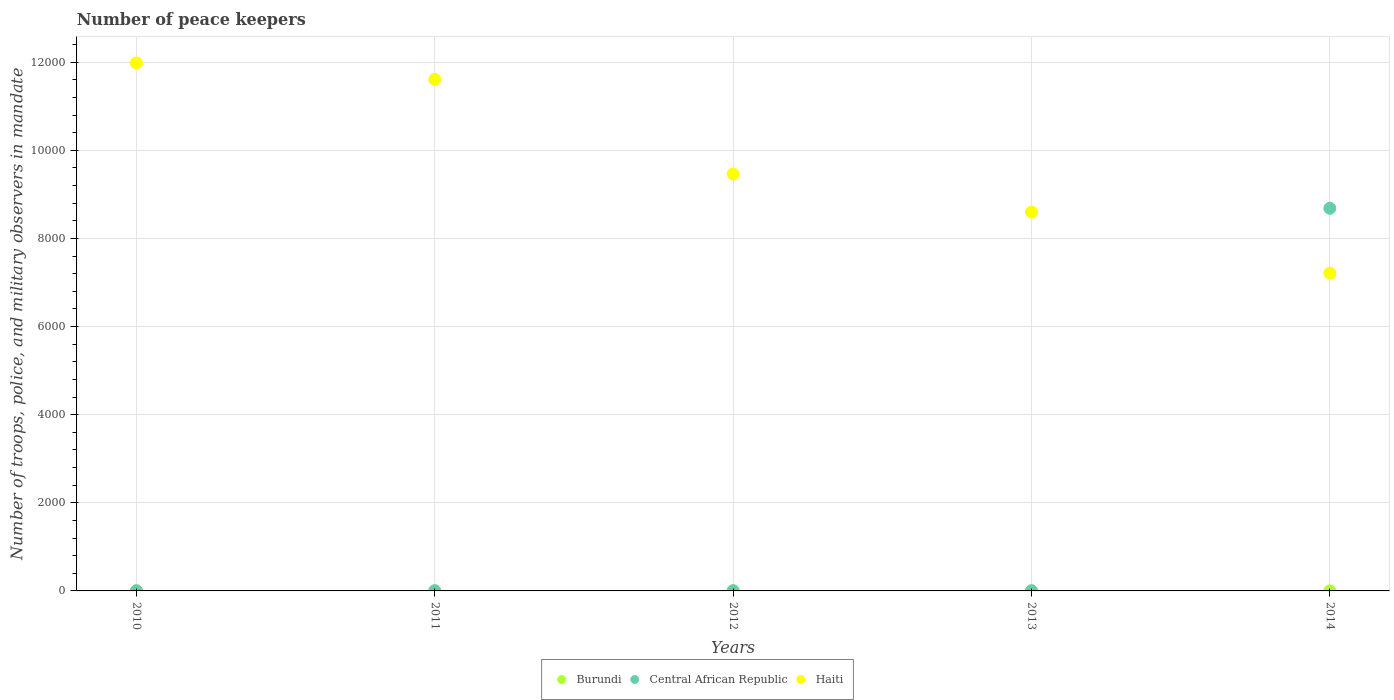How many different coloured dotlines are there?
Keep it short and to the point. 3. Is the number of dotlines equal to the number of legend labels?
Your response must be concise. Yes. What is the number of peace keepers in in Haiti in 2010?
Offer a very short reply. 1.20e+04. Across all years, what is the maximum number of peace keepers in in Burundi?
Offer a terse response. 4. Across all years, what is the minimum number of peace keepers in in Burundi?
Your answer should be very brief. 1. What is the total number of peace keepers in in Burundi in the graph?
Give a very brief answer. 11. What is the difference between the number of peace keepers in in Central African Republic in 2010 and that in 2011?
Your answer should be compact. -1. What is the difference between the number of peace keepers in in Central African Republic in 2013 and the number of peace keepers in in Haiti in 2014?
Provide a short and direct response. -7209. What is the average number of peace keepers in in Burundi per year?
Give a very brief answer. 2.2. In the year 2013, what is the difference between the number of peace keepers in in Central African Republic and number of peace keepers in in Burundi?
Offer a terse response. 2. In how many years, is the number of peace keepers in in Burundi greater than 1200?
Ensure brevity in your answer.  0. What is the ratio of the number of peace keepers in in Haiti in 2011 to that in 2013?
Make the answer very short. 1.35. What is the difference between the highest and the second highest number of peace keepers in in Central African Republic?
Ensure brevity in your answer.  8681. Is the sum of the number of peace keepers in in Burundi in 2011 and 2012 greater than the maximum number of peace keepers in in Haiti across all years?
Your answer should be very brief. No. Does the number of peace keepers in in Central African Republic monotonically increase over the years?
Make the answer very short. No. Is the number of peace keepers in in Central African Republic strictly greater than the number of peace keepers in in Haiti over the years?
Your answer should be compact. No. What is the difference between two consecutive major ticks on the Y-axis?
Provide a short and direct response. 2000. Are the values on the major ticks of Y-axis written in scientific E-notation?
Offer a terse response. No. Does the graph contain grids?
Offer a terse response. Yes. How many legend labels are there?
Give a very brief answer. 3. What is the title of the graph?
Ensure brevity in your answer.  Number of peace keepers. Does "Burkina Faso" appear as one of the legend labels in the graph?
Give a very brief answer. No. What is the label or title of the X-axis?
Keep it short and to the point. Years. What is the label or title of the Y-axis?
Your response must be concise. Number of troops, police, and military observers in mandate. What is the Number of troops, police, and military observers in mandate in Burundi in 2010?
Provide a short and direct response. 4. What is the Number of troops, police, and military observers in mandate in Central African Republic in 2010?
Offer a terse response. 3. What is the Number of troops, police, and military observers in mandate of Haiti in 2010?
Ensure brevity in your answer.  1.20e+04. What is the Number of troops, police, and military observers in mandate in Burundi in 2011?
Provide a succinct answer. 1. What is the Number of troops, police, and military observers in mandate in Central African Republic in 2011?
Offer a terse response. 4. What is the Number of troops, police, and military observers in mandate in Haiti in 2011?
Make the answer very short. 1.16e+04. What is the Number of troops, police, and military observers in mandate of Haiti in 2012?
Give a very brief answer. 9464. What is the Number of troops, police, and military observers in mandate in Central African Republic in 2013?
Your answer should be compact. 4. What is the Number of troops, police, and military observers in mandate in Haiti in 2013?
Your answer should be very brief. 8600. What is the Number of troops, police, and military observers in mandate of Central African Republic in 2014?
Your answer should be very brief. 8685. What is the Number of troops, police, and military observers in mandate of Haiti in 2014?
Your response must be concise. 7213. Across all years, what is the maximum Number of troops, police, and military observers in mandate of Burundi?
Provide a short and direct response. 4. Across all years, what is the maximum Number of troops, police, and military observers in mandate in Central African Republic?
Your answer should be very brief. 8685. Across all years, what is the maximum Number of troops, police, and military observers in mandate in Haiti?
Provide a succinct answer. 1.20e+04. Across all years, what is the minimum Number of troops, police, and military observers in mandate in Burundi?
Provide a succinct answer. 1. Across all years, what is the minimum Number of troops, police, and military observers in mandate of Haiti?
Provide a succinct answer. 7213. What is the total Number of troops, police, and military observers in mandate of Burundi in the graph?
Make the answer very short. 11. What is the total Number of troops, police, and military observers in mandate in Central African Republic in the graph?
Provide a short and direct response. 8700. What is the total Number of troops, police, and military observers in mandate of Haiti in the graph?
Make the answer very short. 4.89e+04. What is the difference between the Number of troops, police, and military observers in mandate in Haiti in 2010 and that in 2011?
Your answer should be compact. 373. What is the difference between the Number of troops, police, and military observers in mandate in Central African Republic in 2010 and that in 2012?
Your answer should be very brief. -1. What is the difference between the Number of troops, police, and military observers in mandate of Haiti in 2010 and that in 2012?
Offer a very short reply. 2520. What is the difference between the Number of troops, police, and military observers in mandate of Burundi in 2010 and that in 2013?
Your response must be concise. 2. What is the difference between the Number of troops, police, and military observers in mandate in Haiti in 2010 and that in 2013?
Give a very brief answer. 3384. What is the difference between the Number of troops, police, and military observers in mandate of Burundi in 2010 and that in 2014?
Give a very brief answer. 2. What is the difference between the Number of troops, police, and military observers in mandate of Central African Republic in 2010 and that in 2014?
Your response must be concise. -8682. What is the difference between the Number of troops, police, and military observers in mandate in Haiti in 2010 and that in 2014?
Your response must be concise. 4771. What is the difference between the Number of troops, police, and military observers in mandate of Burundi in 2011 and that in 2012?
Your answer should be very brief. -1. What is the difference between the Number of troops, police, and military observers in mandate in Haiti in 2011 and that in 2012?
Provide a short and direct response. 2147. What is the difference between the Number of troops, police, and military observers in mandate of Central African Republic in 2011 and that in 2013?
Ensure brevity in your answer.  0. What is the difference between the Number of troops, police, and military observers in mandate in Haiti in 2011 and that in 2013?
Your answer should be very brief. 3011. What is the difference between the Number of troops, police, and military observers in mandate of Central African Republic in 2011 and that in 2014?
Ensure brevity in your answer.  -8681. What is the difference between the Number of troops, police, and military observers in mandate in Haiti in 2011 and that in 2014?
Keep it short and to the point. 4398. What is the difference between the Number of troops, police, and military observers in mandate in Burundi in 2012 and that in 2013?
Offer a very short reply. 0. What is the difference between the Number of troops, police, and military observers in mandate in Central African Republic in 2012 and that in 2013?
Your answer should be very brief. 0. What is the difference between the Number of troops, police, and military observers in mandate in Haiti in 2012 and that in 2013?
Keep it short and to the point. 864. What is the difference between the Number of troops, police, and military observers in mandate of Burundi in 2012 and that in 2014?
Provide a succinct answer. 0. What is the difference between the Number of troops, police, and military observers in mandate in Central African Republic in 2012 and that in 2014?
Provide a short and direct response. -8681. What is the difference between the Number of troops, police, and military observers in mandate of Haiti in 2012 and that in 2014?
Your response must be concise. 2251. What is the difference between the Number of troops, police, and military observers in mandate in Burundi in 2013 and that in 2014?
Ensure brevity in your answer.  0. What is the difference between the Number of troops, police, and military observers in mandate of Central African Republic in 2013 and that in 2014?
Provide a short and direct response. -8681. What is the difference between the Number of troops, police, and military observers in mandate of Haiti in 2013 and that in 2014?
Make the answer very short. 1387. What is the difference between the Number of troops, police, and military observers in mandate of Burundi in 2010 and the Number of troops, police, and military observers in mandate of Central African Republic in 2011?
Make the answer very short. 0. What is the difference between the Number of troops, police, and military observers in mandate of Burundi in 2010 and the Number of troops, police, and military observers in mandate of Haiti in 2011?
Keep it short and to the point. -1.16e+04. What is the difference between the Number of troops, police, and military observers in mandate of Central African Republic in 2010 and the Number of troops, police, and military observers in mandate of Haiti in 2011?
Give a very brief answer. -1.16e+04. What is the difference between the Number of troops, police, and military observers in mandate in Burundi in 2010 and the Number of troops, police, and military observers in mandate in Central African Republic in 2012?
Your answer should be very brief. 0. What is the difference between the Number of troops, police, and military observers in mandate in Burundi in 2010 and the Number of troops, police, and military observers in mandate in Haiti in 2012?
Keep it short and to the point. -9460. What is the difference between the Number of troops, police, and military observers in mandate in Central African Republic in 2010 and the Number of troops, police, and military observers in mandate in Haiti in 2012?
Offer a very short reply. -9461. What is the difference between the Number of troops, police, and military observers in mandate of Burundi in 2010 and the Number of troops, police, and military observers in mandate of Haiti in 2013?
Your answer should be compact. -8596. What is the difference between the Number of troops, police, and military observers in mandate in Central African Republic in 2010 and the Number of troops, police, and military observers in mandate in Haiti in 2013?
Offer a terse response. -8597. What is the difference between the Number of troops, police, and military observers in mandate in Burundi in 2010 and the Number of troops, police, and military observers in mandate in Central African Republic in 2014?
Ensure brevity in your answer.  -8681. What is the difference between the Number of troops, police, and military observers in mandate of Burundi in 2010 and the Number of troops, police, and military observers in mandate of Haiti in 2014?
Keep it short and to the point. -7209. What is the difference between the Number of troops, police, and military observers in mandate of Central African Republic in 2010 and the Number of troops, police, and military observers in mandate of Haiti in 2014?
Give a very brief answer. -7210. What is the difference between the Number of troops, police, and military observers in mandate of Burundi in 2011 and the Number of troops, police, and military observers in mandate of Haiti in 2012?
Your response must be concise. -9463. What is the difference between the Number of troops, police, and military observers in mandate in Central African Republic in 2011 and the Number of troops, police, and military observers in mandate in Haiti in 2012?
Make the answer very short. -9460. What is the difference between the Number of troops, police, and military observers in mandate of Burundi in 2011 and the Number of troops, police, and military observers in mandate of Central African Republic in 2013?
Provide a succinct answer. -3. What is the difference between the Number of troops, police, and military observers in mandate in Burundi in 2011 and the Number of troops, police, and military observers in mandate in Haiti in 2013?
Offer a terse response. -8599. What is the difference between the Number of troops, police, and military observers in mandate of Central African Republic in 2011 and the Number of troops, police, and military observers in mandate of Haiti in 2013?
Offer a terse response. -8596. What is the difference between the Number of troops, police, and military observers in mandate in Burundi in 2011 and the Number of troops, police, and military observers in mandate in Central African Republic in 2014?
Your answer should be very brief. -8684. What is the difference between the Number of troops, police, and military observers in mandate in Burundi in 2011 and the Number of troops, police, and military observers in mandate in Haiti in 2014?
Offer a terse response. -7212. What is the difference between the Number of troops, police, and military observers in mandate of Central African Republic in 2011 and the Number of troops, police, and military observers in mandate of Haiti in 2014?
Your answer should be compact. -7209. What is the difference between the Number of troops, police, and military observers in mandate of Burundi in 2012 and the Number of troops, police, and military observers in mandate of Haiti in 2013?
Provide a short and direct response. -8598. What is the difference between the Number of troops, police, and military observers in mandate of Central African Republic in 2012 and the Number of troops, police, and military observers in mandate of Haiti in 2013?
Your answer should be compact. -8596. What is the difference between the Number of troops, police, and military observers in mandate in Burundi in 2012 and the Number of troops, police, and military observers in mandate in Central African Republic in 2014?
Offer a very short reply. -8683. What is the difference between the Number of troops, police, and military observers in mandate in Burundi in 2012 and the Number of troops, police, and military observers in mandate in Haiti in 2014?
Make the answer very short. -7211. What is the difference between the Number of troops, police, and military observers in mandate in Central African Republic in 2012 and the Number of troops, police, and military observers in mandate in Haiti in 2014?
Offer a terse response. -7209. What is the difference between the Number of troops, police, and military observers in mandate of Burundi in 2013 and the Number of troops, police, and military observers in mandate of Central African Republic in 2014?
Provide a succinct answer. -8683. What is the difference between the Number of troops, police, and military observers in mandate in Burundi in 2013 and the Number of troops, police, and military observers in mandate in Haiti in 2014?
Your answer should be compact. -7211. What is the difference between the Number of troops, police, and military observers in mandate of Central African Republic in 2013 and the Number of troops, police, and military observers in mandate of Haiti in 2014?
Your answer should be very brief. -7209. What is the average Number of troops, police, and military observers in mandate of Burundi per year?
Offer a very short reply. 2.2. What is the average Number of troops, police, and military observers in mandate of Central African Republic per year?
Give a very brief answer. 1740. What is the average Number of troops, police, and military observers in mandate of Haiti per year?
Your answer should be compact. 9774.4. In the year 2010, what is the difference between the Number of troops, police, and military observers in mandate in Burundi and Number of troops, police, and military observers in mandate in Central African Republic?
Make the answer very short. 1. In the year 2010, what is the difference between the Number of troops, police, and military observers in mandate in Burundi and Number of troops, police, and military observers in mandate in Haiti?
Provide a succinct answer. -1.20e+04. In the year 2010, what is the difference between the Number of troops, police, and military observers in mandate of Central African Republic and Number of troops, police, and military observers in mandate of Haiti?
Keep it short and to the point. -1.20e+04. In the year 2011, what is the difference between the Number of troops, police, and military observers in mandate of Burundi and Number of troops, police, and military observers in mandate of Haiti?
Make the answer very short. -1.16e+04. In the year 2011, what is the difference between the Number of troops, police, and military observers in mandate of Central African Republic and Number of troops, police, and military observers in mandate of Haiti?
Your response must be concise. -1.16e+04. In the year 2012, what is the difference between the Number of troops, police, and military observers in mandate in Burundi and Number of troops, police, and military observers in mandate in Haiti?
Offer a very short reply. -9462. In the year 2012, what is the difference between the Number of troops, police, and military observers in mandate of Central African Republic and Number of troops, police, and military observers in mandate of Haiti?
Make the answer very short. -9460. In the year 2013, what is the difference between the Number of troops, police, and military observers in mandate of Burundi and Number of troops, police, and military observers in mandate of Central African Republic?
Offer a terse response. -2. In the year 2013, what is the difference between the Number of troops, police, and military observers in mandate in Burundi and Number of troops, police, and military observers in mandate in Haiti?
Provide a short and direct response. -8598. In the year 2013, what is the difference between the Number of troops, police, and military observers in mandate of Central African Republic and Number of troops, police, and military observers in mandate of Haiti?
Your answer should be compact. -8596. In the year 2014, what is the difference between the Number of troops, police, and military observers in mandate of Burundi and Number of troops, police, and military observers in mandate of Central African Republic?
Offer a terse response. -8683. In the year 2014, what is the difference between the Number of troops, police, and military observers in mandate in Burundi and Number of troops, police, and military observers in mandate in Haiti?
Your answer should be very brief. -7211. In the year 2014, what is the difference between the Number of troops, police, and military observers in mandate of Central African Republic and Number of troops, police, and military observers in mandate of Haiti?
Provide a short and direct response. 1472. What is the ratio of the Number of troops, police, and military observers in mandate of Central African Republic in 2010 to that in 2011?
Keep it short and to the point. 0.75. What is the ratio of the Number of troops, police, and military observers in mandate of Haiti in 2010 to that in 2011?
Ensure brevity in your answer.  1.03. What is the ratio of the Number of troops, police, and military observers in mandate of Burundi in 2010 to that in 2012?
Ensure brevity in your answer.  2. What is the ratio of the Number of troops, police, and military observers in mandate of Central African Republic in 2010 to that in 2012?
Keep it short and to the point. 0.75. What is the ratio of the Number of troops, police, and military observers in mandate in Haiti in 2010 to that in 2012?
Ensure brevity in your answer.  1.27. What is the ratio of the Number of troops, police, and military observers in mandate of Central African Republic in 2010 to that in 2013?
Keep it short and to the point. 0.75. What is the ratio of the Number of troops, police, and military observers in mandate of Haiti in 2010 to that in 2013?
Provide a succinct answer. 1.39. What is the ratio of the Number of troops, police, and military observers in mandate of Haiti in 2010 to that in 2014?
Keep it short and to the point. 1.66. What is the ratio of the Number of troops, police, and military observers in mandate in Burundi in 2011 to that in 2012?
Provide a short and direct response. 0.5. What is the ratio of the Number of troops, police, and military observers in mandate of Haiti in 2011 to that in 2012?
Offer a terse response. 1.23. What is the ratio of the Number of troops, police, and military observers in mandate in Central African Republic in 2011 to that in 2013?
Your response must be concise. 1. What is the ratio of the Number of troops, police, and military observers in mandate of Haiti in 2011 to that in 2013?
Offer a very short reply. 1.35. What is the ratio of the Number of troops, police, and military observers in mandate in Burundi in 2011 to that in 2014?
Provide a short and direct response. 0.5. What is the ratio of the Number of troops, police, and military observers in mandate of Central African Republic in 2011 to that in 2014?
Offer a terse response. 0. What is the ratio of the Number of troops, police, and military observers in mandate in Haiti in 2011 to that in 2014?
Offer a very short reply. 1.61. What is the ratio of the Number of troops, police, and military observers in mandate of Haiti in 2012 to that in 2013?
Your answer should be very brief. 1.1. What is the ratio of the Number of troops, police, and military observers in mandate in Burundi in 2012 to that in 2014?
Make the answer very short. 1. What is the ratio of the Number of troops, police, and military observers in mandate of Haiti in 2012 to that in 2014?
Ensure brevity in your answer.  1.31. What is the ratio of the Number of troops, police, and military observers in mandate of Burundi in 2013 to that in 2014?
Ensure brevity in your answer.  1. What is the ratio of the Number of troops, police, and military observers in mandate in Central African Republic in 2013 to that in 2014?
Offer a terse response. 0. What is the ratio of the Number of troops, police, and military observers in mandate of Haiti in 2013 to that in 2014?
Keep it short and to the point. 1.19. What is the difference between the highest and the second highest Number of troops, police, and military observers in mandate of Burundi?
Make the answer very short. 2. What is the difference between the highest and the second highest Number of troops, police, and military observers in mandate in Central African Republic?
Your answer should be very brief. 8681. What is the difference between the highest and the second highest Number of troops, police, and military observers in mandate in Haiti?
Give a very brief answer. 373. What is the difference between the highest and the lowest Number of troops, police, and military observers in mandate of Burundi?
Offer a terse response. 3. What is the difference between the highest and the lowest Number of troops, police, and military observers in mandate in Central African Republic?
Provide a short and direct response. 8682. What is the difference between the highest and the lowest Number of troops, police, and military observers in mandate of Haiti?
Your answer should be very brief. 4771. 